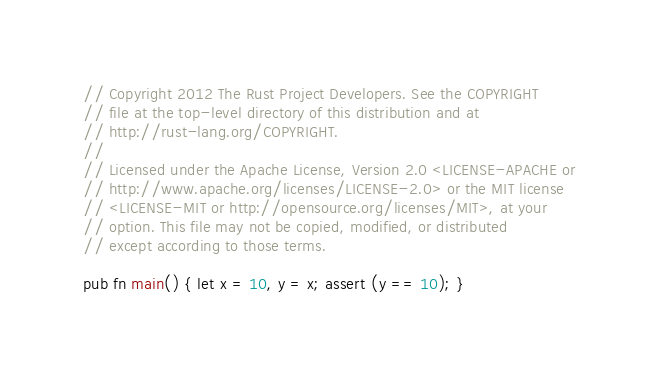Convert code to text. <code><loc_0><loc_0><loc_500><loc_500><_Rust_>// Copyright 2012 The Rust Project Developers. See the COPYRIGHT
// file at the top-level directory of this distribution and at
// http://rust-lang.org/COPYRIGHT.
//
// Licensed under the Apache License, Version 2.0 <LICENSE-APACHE or
// http://www.apache.org/licenses/LICENSE-2.0> or the MIT license
// <LICENSE-MIT or http://opensource.org/licenses/MIT>, at your
// option. This file may not be copied, modified, or distributed
// except according to those terms.

pub fn main() { let x = 10, y = x; assert (y == 10); }
</code> 